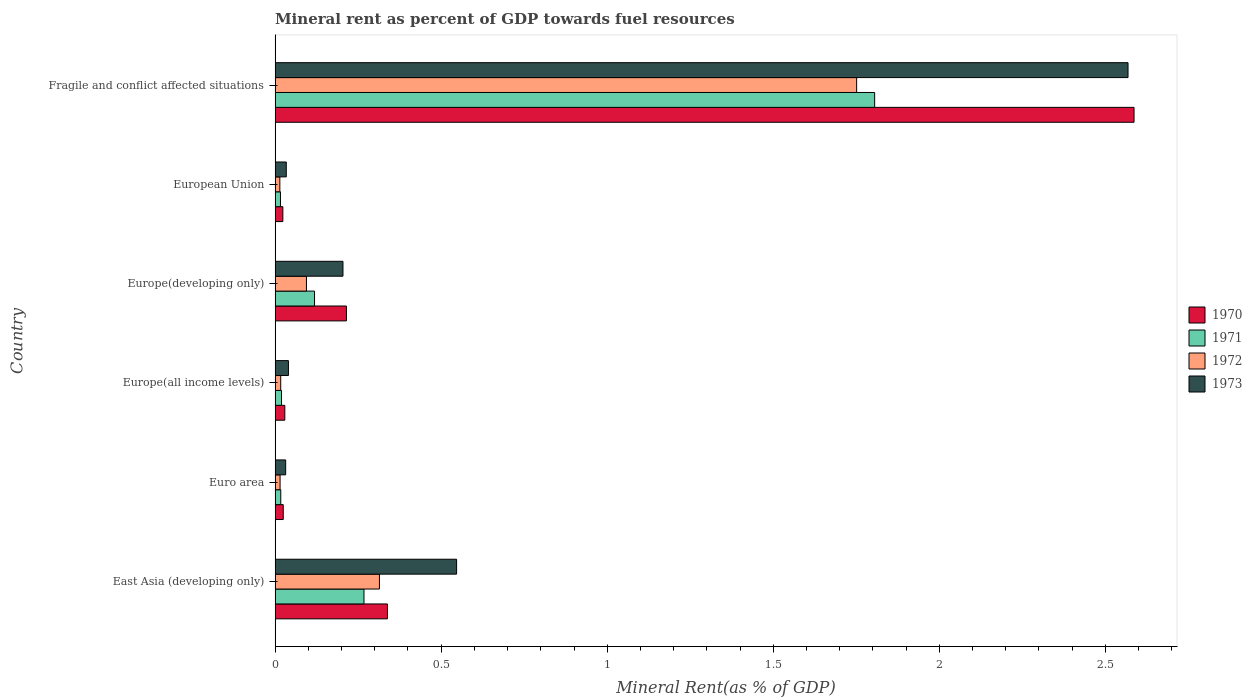How many groups of bars are there?
Offer a terse response. 6. Are the number of bars per tick equal to the number of legend labels?
Your response must be concise. Yes. Are the number of bars on each tick of the Y-axis equal?
Make the answer very short. Yes. How many bars are there on the 6th tick from the bottom?
Provide a short and direct response. 4. What is the label of the 5th group of bars from the top?
Keep it short and to the point. Euro area. What is the mineral rent in 1970 in East Asia (developing only)?
Offer a very short reply. 0.34. Across all countries, what is the maximum mineral rent in 1973?
Keep it short and to the point. 2.57. Across all countries, what is the minimum mineral rent in 1972?
Provide a short and direct response. 0.01. In which country was the mineral rent in 1973 maximum?
Ensure brevity in your answer.  Fragile and conflict affected situations. In which country was the mineral rent in 1973 minimum?
Your response must be concise. Euro area. What is the total mineral rent in 1971 in the graph?
Make the answer very short. 2.24. What is the difference between the mineral rent in 1973 in East Asia (developing only) and that in Europe(all income levels)?
Your answer should be compact. 0.51. What is the difference between the mineral rent in 1971 in Euro area and the mineral rent in 1970 in Europe(developing only)?
Your answer should be compact. -0.2. What is the average mineral rent in 1970 per country?
Your answer should be compact. 0.54. What is the difference between the mineral rent in 1970 and mineral rent in 1972 in European Union?
Offer a terse response. 0.01. In how many countries, is the mineral rent in 1973 greater than 1.4 %?
Your answer should be compact. 1. What is the ratio of the mineral rent in 1972 in Europe(all income levels) to that in Fragile and conflict affected situations?
Your answer should be compact. 0.01. Is the difference between the mineral rent in 1970 in Euro area and Europe(all income levels) greater than the difference between the mineral rent in 1972 in Euro area and Europe(all income levels)?
Provide a succinct answer. No. What is the difference between the highest and the second highest mineral rent in 1970?
Provide a short and direct response. 2.25. What is the difference between the highest and the lowest mineral rent in 1970?
Your response must be concise. 2.56. In how many countries, is the mineral rent in 1973 greater than the average mineral rent in 1973 taken over all countries?
Keep it short and to the point. 1. What does the 3rd bar from the top in Euro area represents?
Your response must be concise. 1971. What does the 4th bar from the bottom in Euro area represents?
Offer a terse response. 1973. How many bars are there?
Provide a succinct answer. 24. Are all the bars in the graph horizontal?
Provide a short and direct response. Yes. How many countries are there in the graph?
Provide a succinct answer. 6. Are the values on the major ticks of X-axis written in scientific E-notation?
Give a very brief answer. No. How are the legend labels stacked?
Ensure brevity in your answer.  Vertical. What is the title of the graph?
Your answer should be very brief. Mineral rent as percent of GDP towards fuel resources. Does "1975" appear as one of the legend labels in the graph?
Your response must be concise. No. What is the label or title of the X-axis?
Give a very brief answer. Mineral Rent(as % of GDP). What is the Mineral Rent(as % of GDP) in 1970 in East Asia (developing only)?
Your answer should be compact. 0.34. What is the Mineral Rent(as % of GDP) of 1971 in East Asia (developing only)?
Make the answer very short. 0.27. What is the Mineral Rent(as % of GDP) in 1972 in East Asia (developing only)?
Your answer should be very brief. 0.31. What is the Mineral Rent(as % of GDP) in 1973 in East Asia (developing only)?
Provide a succinct answer. 0.55. What is the Mineral Rent(as % of GDP) of 1970 in Euro area?
Your response must be concise. 0.02. What is the Mineral Rent(as % of GDP) in 1971 in Euro area?
Your answer should be very brief. 0.02. What is the Mineral Rent(as % of GDP) in 1972 in Euro area?
Offer a terse response. 0.02. What is the Mineral Rent(as % of GDP) in 1973 in Euro area?
Ensure brevity in your answer.  0.03. What is the Mineral Rent(as % of GDP) in 1970 in Europe(all income levels)?
Your answer should be very brief. 0.03. What is the Mineral Rent(as % of GDP) of 1971 in Europe(all income levels)?
Provide a succinct answer. 0.02. What is the Mineral Rent(as % of GDP) in 1972 in Europe(all income levels)?
Give a very brief answer. 0.02. What is the Mineral Rent(as % of GDP) in 1973 in Europe(all income levels)?
Keep it short and to the point. 0.04. What is the Mineral Rent(as % of GDP) in 1970 in Europe(developing only)?
Your answer should be compact. 0.21. What is the Mineral Rent(as % of GDP) in 1971 in Europe(developing only)?
Offer a very short reply. 0.12. What is the Mineral Rent(as % of GDP) in 1972 in Europe(developing only)?
Provide a succinct answer. 0.09. What is the Mineral Rent(as % of GDP) of 1973 in Europe(developing only)?
Provide a short and direct response. 0.2. What is the Mineral Rent(as % of GDP) in 1970 in European Union?
Provide a succinct answer. 0.02. What is the Mineral Rent(as % of GDP) of 1971 in European Union?
Make the answer very short. 0.02. What is the Mineral Rent(as % of GDP) in 1972 in European Union?
Provide a short and direct response. 0.01. What is the Mineral Rent(as % of GDP) of 1973 in European Union?
Offer a very short reply. 0.03. What is the Mineral Rent(as % of GDP) of 1970 in Fragile and conflict affected situations?
Ensure brevity in your answer.  2.59. What is the Mineral Rent(as % of GDP) of 1971 in Fragile and conflict affected situations?
Your answer should be very brief. 1.81. What is the Mineral Rent(as % of GDP) of 1972 in Fragile and conflict affected situations?
Offer a terse response. 1.75. What is the Mineral Rent(as % of GDP) in 1973 in Fragile and conflict affected situations?
Your answer should be very brief. 2.57. Across all countries, what is the maximum Mineral Rent(as % of GDP) in 1970?
Provide a succinct answer. 2.59. Across all countries, what is the maximum Mineral Rent(as % of GDP) of 1971?
Your response must be concise. 1.81. Across all countries, what is the maximum Mineral Rent(as % of GDP) of 1972?
Offer a terse response. 1.75. Across all countries, what is the maximum Mineral Rent(as % of GDP) of 1973?
Keep it short and to the point. 2.57. Across all countries, what is the minimum Mineral Rent(as % of GDP) in 1970?
Make the answer very short. 0.02. Across all countries, what is the minimum Mineral Rent(as % of GDP) of 1971?
Keep it short and to the point. 0.02. Across all countries, what is the minimum Mineral Rent(as % of GDP) in 1972?
Ensure brevity in your answer.  0.01. Across all countries, what is the minimum Mineral Rent(as % of GDP) of 1973?
Offer a very short reply. 0.03. What is the total Mineral Rent(as % of GDP) in 1970 in the graph?
Provide a short and direct response. 3.22. What is the total Mineral Rent(as % of GDP) in 1971 in the graph?
Offer a terse response. 2.24. What is the total Mineral Rent(as % of GDP) in 1972 in the graph?
Give a very brief answer. 2.21. What is the total Mineral Rent(as % of GDP) of 1973 in the graph?
Provide a short and direct response. 3.42. What is the difference between the Mineral Rent(as % of GDP) in 1970 in East Asia (developing only) and that in Euro area?
Your response must be concise. 0.31. What is the difference between the Mineral Rent(as % of GDP) of 1971 in East Asia (developing only) and that in Euro area?
Your response must be concise. 0.25. What is the difference between the Mineral Rent(as % of GDP) of 1972 in East Asia (developing only) and that in Euro area?
Your response must be concise. 0.3. What is the difference between the Mineral Rent(as % of GDP) of 1973 in East Asia (developing only) and that in Euro area?
Offer a terse response. 0.51. What is the difference between the Mineral Rent(as % of GDP) in 1970 in East Asia (developing only) and that in Europe(all income levels)?
Your response must be concise. 0.31. What is the difference between the Mineral Rent(as % of GDP) of 1971 in East Asia (developing only) and that in Europe(all income levels)?
Provide a succinct answer. 0.25. What is the difference between the Mineral Rent(as % of GDP) of 1972 in East Asia (developing only) and that in Europe(all income levels)?
Offer a terse response. 0.3. What is the difference between the Mineral Rent(as % of GDP) of 1973 in East Asia (developing only) and that in Europe(all income levels)?
Offer a terse response. 0.51. What is the difference between the Mineral Rent(as % of GDP) in 1970 in East Asia (developing only) and that in Europe(developing only)?
Your answer should be compact. 0.12. What is the difference between the Mineral Rent(as % of GDP) in 1971 in East Asia (developing only) and that in Europe(developing only)?
Your answer should be compact. 0.15. What is the difference between the Mineral Rent(as % of GDP) in 1972 in East Asia (developing only) and that in Europe(developing only)?
Your response must be concise. 0.22. What is the difference between the Mineral Rent(as % of GDP) of 1973 in East Asia (developing only) and that in Europe(developing only)?
Keep it short and to the point. 0.34. What is the difference between the Mineral Rent(as % of GDP) in 1970 in East Asia (developing only) and that in European Union?
Your answer should be compact. 0.31. What is the difference between the Mineral Rent(as % of GDP) in 1971 in East Asia (developing only) and that in European Union?
Your answer should be very brief. 0.25. What is the difference between the Mineral Rent(as % of GDP) in 1972 in East Asia (developing only) and that in European Union?
Give a very brief answer. 0.3. What is the difference between the Mineral Rent(as % of GDP) in 1973 in East Asia (developing only) and that in European Union?
Give a very brief answer. 0.51. What is the difference between the Mineral Rent(as % of GDP) of 1970 in East Asia (developing only) and that in Fragile and conflict affected situations?
Your answer should be very brief. -2.25. What is the difference between the Mineral Rent(as % of GDP) in 1971 in East Asia (developing only) and that in Fragile and conflict affected situations?
Your answer should be very brief. -1.54. What is the difference between the Mineral Rent(as % of GDP) in 1972 in East Asia (developing only) and that in Fragile and conflict affected situations?
Give a very brief answer. -1.44. What is the difference between the Mineral Rent(as % of GDP) of 1973 in East Asia (developing only) and that in Fragile and conflict affected situations?
Provide a succinct answer. -2.02. What is the difference between the Mineral Rent(as % of GDP) of 1970 in Euro area and that in Europe(all income levels)?
Provide a short and direct response. -0. What is the difference between the Mineral Rent(as % of GDP) in 1971 in Euro area and that in Europe(all income levels)?
Give a very brief answer. -0. What is the difference between the Mineral Rent(as % of GDP) of 1972 in Euro area and that in Europe(all income levels)?
Provide a short and direct response. -0. What is the difference between the Mineral Rent(as % of GDP) in 1973 in Euro area and that in Europe(all income levels)?
Provide a short and direct response. -0.01. What is the difference between the Mineral Rent(as % of GDP) of 1970 in Euro area and that in Europe(developing only)?
Provide a succinct answer. -0.19. What is the difference between the Mineral Rent(as % of GDP) in 1971 in Euro area and that in Europe(developing only)?
Offer a very short reply. -0.1. What is the difference between the Mineral Rent(as % of GDP) in 1972 in Euro area and that in Europe(developing only)?
Provide a short and direct response. -0.08. What is the difference between the Mineral Rent(as % of GDP) in 1973 in Euro area and that in Europe(developing only)?
Your answer should be very brief. -0.17. What is the difference between the Mineral Rent(as % of GDP) of 1970 in Euro area and that in European Union?
Keep it short and to the point. 0. What is the difference between the Mineral Rent(as % of GDP) of 1971 in Euro area and that in European Union?
Your answer should be very brief. 0. What is the difference between the Mineral Rent(as % of GDP) in 1972 in Euro area and that in European Union?
Provide a succinct answer. 0. What is the difference between the Mineral Rent(as % of GDP) of 1973 in Euro area and that in European Union?
Your answer should be very brief. -0. What is the difference between the Mineral Rent(as % of GDP) of 1970 in Euro area and that in Fragile and conflict affected situations?
Offer a very short reply. -2.56. What is the difference between the Mineral Rent(as % of GDP) of 1971 in Euro area and that in Fragile and conflict affected situations?
Give a very brief answer. -1.79. What is the difference between the Mineral Rent(as % of GDP) in 1972 in Euro area and that in Fragile and conflict affected situations?
Keep it short and to the point. -1.74. What is the difference between the Mineral Rent(as % of GDP) in 1973 in Euro area and that in Fragile and conflict affected situations?
Keep it short and to the point. -2.54. What is the difference between the Mineral Rent(as % of GDP) of 1970 in Europe(all income levels) and that in Europe(developing only)?
Provide a short and direct response. -0.19. What is the difference between the Mineral Rent(as % of GDP) of 1971 in Europe(all income levels) and that in Europe(developing only)?
Provide a short and direct response. -0.1. What is the difference between the Mineral Rent(as % of GDP) in 1972 in Europe(all income levels) and that in Europe(developing only)?
Provide a succinct answer. -0.08. What is the difference between the Mineral Rent(as % of GDP) in 1973 in Europe(all income levels) and that in Europe(developing only)?
Make the answer very short. -0.16. What is the difference between the Mineral Rent(as % of GDP) of 1970 in Europe(all income levels) and that in European Union?
Offer a terse response. 0.01. What is the difference between the Mineral Rent(as % of GDP) of 1971 in Europe(all income levels) and that in European Union?
Keep it short and to the point. 0. What is the difference between the Mineral Rent(as % of GDP) of 1972 in Europe(all income levels) and that in European Union?
Provide a short and direct response. 0. What is the difference between the Mineral Rent(as % of GDP) in 1973 in Europe(all income levels) and that in European Union?
Offer a terse response. 0.01. What is the difference between the Mineral Rent(as % of GDP) in 1970 in Europe(all income levels) and that in Fragile and conflict affected situations?
Your answer should be compact. -2.56. What is the difference between the Mineral Rent(as % of GDP) in 1971 in Europe(all income levels) and that in Fragile and conflict affected situations?
Provide a short and direct response. -1.79. What is the difference between the Mineral Rent(as % of GDP) in 1972 in Europe(all income levels) and that in Fragile and conflict affected situations?
Provide a succinct answer. -1.73. What is the difference between the Mineral Rent(as % of GDP) in 1973 in Europe(all income levels) and that in Fragile and conflict affected situations?
Your answer should be very brief. -2.53. What is the difference between the Mineral Rent(as % of GDP) of 1970 in Europe(developing only) and that in European Union?
Your answer should be very brief. 0.19. What is the difference between the Mineral Rent(as % of GDP) in 1971 in Europe(developing only) and that in European Union?
Provide a short and direct response. 0.1. What is the difference between the Mineral Rent(as % of GDP) of 1972 in Europe(developing only) and that in European Union?
Keep it short and to the point. 0.08. What is the difference between the Mineral Rent(as % of GDP) in 1973 in Europe(developing only) and that in European Union?
Offer a terse response. 0.17. What is the difference between the Mineral Rent(as % of GDP) in 1970 in Europe(developing only) and that in Fragile and conflict affected situations?
Your answer should be compact. -2.37. What is the difference between the Mineral Rent(as % of GDP) in 1971 in Europe(developing only) and that in Fragile and conflict affected situations?
Your answer should be compact. -1.69. What is the difference between the Mineral Rent(as % of GDP) in 1972 in Europe(developing only) and that in Fragile and conflict affected situations?
Offer a terse response. -1.66. What is the difference between the Mineral Rent(as % of GDP) in 1973 in Europe(developing only) and that in Fragile and conflict affected situations?
Give a very brief answer. -2.36. What is the difference between the Mineral Rent(as % of GDP) of 1970 in European Union and that in Fragile and conflict affected situations?
Offer a very short reply. -2.56. What is the difference between the Mineral Rent(as % of GDP) in 1971 in European Union and that in Fragile and conflict affected situations?
Your answer should be compact. -1.79. What is the difference between the Mineral Rent(as % of GDP) of 1972 in European Union and that in Fragile and conflict affected situations?
Give a very brief answer. -1.74. What is the difference between the Mineral Rent(as % of GDP) in 1973 in European Union and that in Fragile and conflict affected situations?
Your answer should be compact. -2.53. What is the difference between the Mineral Rent(as % of GDP) of 1970 in East Asia (developing only) and the Mineral Rent(as % of GDP) of 1971 in Euro area?
Your answer should be compact. 0.32. What is the difference between the Mineral Rent(as % of GDP) of 1970 in East Asia (developing only) and the Mineral Rent(as % of GDP) of 1972 in Euro area?
Your answer should be very brief. 0.32. What is the difference between the Mineral Rent(as % of GDP) of 1970 in East Asia (developing only) and the Mineral Rent(as % of GDP) of 1973 in Euro area?
Make the answer very short. 0.31. What is the difference between the Mineral Rent(as % of GDP) of 1971 in East Asia (developing only) and the Mineral Rent(as % of GDP) of 1972 in Euro area?
Ensure brevity in your answer.  0.25. What is the difference between the Mineral Rent(as % of GDP) in 1971 in East Asia (developing only) and the Mineral Rent(as % of GDP) in 1973 in Euro area?
Make the answer very short. 0.24. What is the difference between the Mineral Rent(as % of GDP) of 1972 in East Asia (developing only) and the Mineral Rent(as % of GDP) of 1973 in Euro area?
Offer a terse response. 0.28. What is the difference between the Mineral Rent(as % of GDP) in 1970 in East Asia (developing only) and the Mineral Rent(as % of GDP) in 1971 in Europe(all income levels)?
Make the answer very short. 0.32. What is the difference between the Mineral Rent(as % of GDP) in 1970 in East Asia (developing only) and the Mineral Rent(as % of GDP) in 1972 in Europe(all income levels)?
Provide a succinct answer. 0.32. What is the difference between the Mineral Rent(as % of GDP) in 1970 in East Asia (developing only) and the Mineral Rent(as % of GDP) in 1973 in Europe(all income levels)?
Your answer should be very brief. 0.3. What is the difference between the Mineral Rent(as % of GDP) of 1971 in East Asia (developing only) and the Mineral Rent(as % of GDP) of 1972 in Europe(all income levels)?
Offer a terse response. 0.25. What is the difference between the Mineral Rent(as % of GDP) of 1971 in East Asia (developing only) and the Mineral Rent(as % of GDP) of 1973 in Europe(all income levels)?
Give a very brief answer. 0.23. What is the difference between the Mineral Rent(as % of GDP) in 1972 in East Asia (developing only) and the Mineral Rent(as % of GDP) in 1973 in Europe(all income levels)?
Give a very brief answer. 0.27. What is the difference between the Mineral Rent(as % of GDP) in 1970 in East Asia (developing only) and the Mineral Rent(as % of GDP) in 1971 in Europe(developing only)?
Your answer should be compact. 0.22. What is the difference between the Mineral Rent(as % of GDP) in 1970 in East Asia (developing only) and the Mineral Rent(as % of GDP) in 1972 in Europe(developing only)?
Offer a terse response. 0.24. What is the difference between the Mineral Rent(as % of GDP) in 1970 in East Asia (developing only) and the Mineral Rent(as % of GDP) in 1973 in Europe(developing only)?
Keep it short and to the point. 0.13. What is the difference between the Mineral Rent(as % of GDP) of 1971 in East Asia (developing only) and the Mineral Rent(as % of GDP) of 1972 in Europe(developing only)?
Your answer should be compact. 0.17. What is the difference between the Mineral Rent(as % of GDP) of 1971 in East Asia (developing only) and the Mineral Rent(as % of GDP) of 1973 in Europe(developing only)?
Your answer should be compact. 0.06. What is the difference between the Mineral Rent(as % of GDP) of 1972 in East Asia (developing only) and the Mineral Rent(as % of GDP) of 1973 in Europe(developing only)?
Your response must be concise. 0.11. What is the difference between the Mineral Rent(as % of GDP) in 1970 in East Asia (developing only) and the Mineral Rent(as % of GDP) in 1971 in European Union?
Offer a very short reply. 0.32. What is the difference between the Mineral Rent(as % of GDP) of 1970 in East Asia (developing only) and the Mineral Rent(as % of GDP) of 1972 in European Union?
Offer a terse response. 0.32. What is the difference between the Mineral Rent(as % of GDP) in 1970 in East Asia (developing only) and the Mineral Rent(as % of GDP) in 1973 in European Union?
Ensure brevity in your answer.  0.3. What is the difference between the Mineral Rent(as % of GDP) in 1971 in East Asia (developing only) and the Mineral Rent(as % of GDP) in 1972 in European Union?
Ensure brevity in your answer.  0.25. What is the difference between the Mineral Rent(as % of GDP) in 1971 in East Asia (developing only) and the Mineral Rent(as % of GDP) in 1973 in European Union?
Your answer should be very brief. 0.23. What is the difference between the Mineral Rent(as % of GDP) in 1972 in East Asia (developing only) and the Mineral Rent(as % of GDP) in 1973 in European Union?
Offer a very short reply. 0.28. What is the difference between the Mineral Rent(as % of GDP) of 1970 in East Asia (developing only) and the Mineral Rent(as % of GDP) of 1971 in Fragile and conflict affected situations?
Your answer should be very brief. -1.47. What is the difference between the Mineral Rent(as % of GDP) in 1970 in East Asia (developing only) and the Mineral Rent(as % of GDP) in 1972 in Fragile and conflict affected situations?
Your response must be concise. -1.41. What is the difference between the Mineral Rent(as % of GDP) of 1970 in East Asia (developing only) and the Mineral Rent(as % of GDP) of 1973 in Fragile and conflict affected situations?
Your answer should be compact. -2.23. What is the difference between the Mineral Rent(as % of GDP) in 1971 in East Asia (developing only) and the Mineral Rent(as % of GDP) in 1972 in Fragile and conflict affected situations?
Your answer should be compact. -1.48. What is the difference between the Mineral Rent(as % of GDP) in 1971 in East Asia (developing only) and the Mineral Rent(as % of GDP) in 1973 in Fragile and conflict affected situations?
Make the answer very short. -2.3. What is the difference between the Mineral Rent(as % of GDP) in 1972 in East Asia (developing only) and the Mineral Rent(as % of GDP) in 1973 in Fragile and conflict affected situations?
Provide a succinct answer. -2.25. What is the difference between the Mineral Rent(as % of GDP) of 1970 in Euro area and the Mineral Rent(as % of GDP) of 1971 in Europe(all income levels)?
Your answer should be compact. 0.01. What is the difference between the Mineral Rent(as % of GDP) of 1970 in Euro area and the Mineral Rent(as % of GDP) of 1972 in Europe(all income levels)?
Ensure brevity in your answer.  0.01. What is the difference between the Mineral Rent(as % of GDP) in 1970 in Euro area and the Mineral Rent(as % of GDP) in 1973 in Europe(all income levels)?
Offer a very short reply. -0.02. What is the difference between the Mineral Rent(as % of GDP) in 1971 in Euro area and the Mineral Rent(as % of GDP) in 1973 in Europe(all income levels)?
Keep it short and to the point. -0.02. What is the difference between the Mineral Rent(as % of GDP) of 1972 in Euro area and the Mineral Rent(as % of GDP) of 1973 in Europe(all income levels)?
Your answer should be compact. -0.03. What is the difference between the Mineral Rent(as % of GDP) of 1970 in Euro area and the Mineral Rent(as % of GDP) of 1971 in Europe(developing only)?
Your answer should be very brief. -0.09. What is the difference between the Mineral Rent(as % of GDP) of 1970 in Euro area and the Mineral Rent(as % of GDP) of 1972 in Europe(developing only)?
Ensure brevity in your answer.  -0.07. What is the difference between the Mineral Rent(as % of GDP) in 1970 in Euro area and the Mineral Rent(as % of GDP) in 1973 in Europe(developing only)?
Make the answer very short. -0.18. What is the difference between the Mineral Rent(as % of GDP) of 1971 in Euro area and the Mineral Rent(as % of GDP) of 1972 in Europe(developing only)?
Make the answer very short. -0.08. What is the difference between the Mineral Rent(as % of GDP) in 1971 in Euro area and the Mineral Rent(as % of GDP) in 1973 in Europe(developing only)?
Offer a terse response. -0.19. What is the difference between the Mineral Rent(as % of GDP) of 1972 in Euro area and the Mineral Rent(as % of GDP) of 1973 in Europe(developing only)?
Offer a terse response. -0.19. What is the difference between the Mineral Rent(as % of GDP) of 1970 in Euro area and the Mineral Rent(as % of GDP) of 1971 in European Union?
Provide a short and direct response. 0.01. What is the difference between the Mineral Rent(as % of GDP) of 1970 in Euro area and the Mineral Rent(as % of GDP) of 1972 in European Union?
Provide a short and direct response. 0.01. What is the difference between the Mineral Rent(as % of GDP) of 1970 in Euro area and the Mineral Rent(as % of GDP) of 1973 in European Union?
Ensure brevity in your answer.  -0.01. What is the difference between the Mineral Rent(as % of GDP) of 1971 in Euro area and the Mineral Rent(as % of GDP) of 1972 in European Union?
Offer a very short reply. 0. What is the difference between the Mineral Rent(as % of GDP) in 1971 in Euro area and the Mineral Rent(as % of GDP) in 1973 in European Union?
Offer a very short reply. -0.02. What is the difference between the Mineral Rent(as % of GDP) in 1972 in Euro area and the Mineral Rent(as % of GDP) in 1973 in European Union?
Ensure brevity in your answer.  -0.02. What is the difference between the Mineral Rent(as % of GDP) of 1970 in Euro area and the Mineral Rent(as % of GDP) of 1971 in Fragile and conflict affected situations?
Make the answer very short. -1.78. What is the difference between the Mineral Rent(as % of GDP) of 1970 in Euro area and the Mineral Rent(as % of GDP) of 1972 in Fragile and conflict affected situations?
Offer a very short reply. -1.73. What is the difference between the Mineral Rent(as % of GDP) of 1970 in Euro area and the Mineral Rent(as % of GDP) of 1973 in Fragile and conflict affected situations?
Your answer should be compact. -2.54. What is the difference between the Mineral Rent(as % of GDP) of 1971 in Euro area and the Mineral Rent(as % of GDP) of 1972 in Fragile and conflict affected situations?
Give a very brief answer. -1.73. What is the difference between the Mineral Rent(as % of GDP) of 1971 in Euro area and the Mineral Rent(as % of GDP) of 1973 in Fragile and conflict affected situations?
Offer a terse response. -2.55. What is the difference between the Mineral Rent(as % of GDP) of 1972 in Euro area and the Mineral Rent(as % of GDP) of 1973 in Fragile and conflict affected situations?
Make the answer very short. -2.55. What is the difference between the Mineral Rent(as % of GDP) of 1970 in Europe(all income levels) and the Mineral Rent(as % of GDP) of 1971 in Europe(developing only)?
Make the answer very short. -0.09. What is the difference between the Mineral Rent(as % of GDP) of 1970 in Europe(all income levels) and the Mineral Rent(as % of GDP) of 1972 in Europe(developing only)?
Offer a terse response. -0.07. What is the difference between the Mineral Rent(as % of GDP) in 1970 in Europe(all income levels) and the Mineral Rent(as % of GDP) in 1973 in Europe(developing only)?
Provide a succinct answer. -0.18. What is the difference between the Mineral Rent(as % of GDP) in 1971 in Europe(all income levels) and the Mineral Rent(as % of GDP) in 1972 in Europe(developing only)?
Ensure brevity in your answer.  -0.08. What is the difference between the Mineral Rent(as % of GDP) of 1971 in Europe(all income levels) and the Mineral Rent(as % of GDP) of 1973 in Europe(developing only)?
Your response must be concise. -0.18. What is the difference between the Mineral Rent(as % of GDP) in 1972 in Europe(all income levels) and the Mineral Rent(as % of GDP) in 1973 in Europe(developing only)?
Make the answer very short. -0.19. What is the difference between the Mineral Rent(as % of GDP) of 1970 in Europe(all income levels) and the Mineral Rent(as % of GDP) of 1971 in European Union?
Offer a very short reply. 0.01. What is the difference between the Mineral Rent(as % of GDP) in 1970 in Europe(all income levels) and the Mineral Rent(as % of GDP) in 1972 in European Union?
Ensure brevity in your answer.  0.01. What is the difference between the Mineral Rent(as % of GDP) of 1970 in Europe(all income levels) and the Mineral Rent(as % of GDP) of 1973 in European Union?
Make the answer very short. -0. What is the difference between the Mineral Rent(as % of GDP) in 1971 in Europe(all income levels) and the Mineral Rent(as % of GDP) in 1972 in European Union?
Provide a succinct answer. 0.01. What is the difference between the Mineral Rent(as % of GDP) of 1971 in Europe(all income levels) and the Mineral Rent(as % of GDP) of 1973 in European Union?
Your response must be concise. -0.01. What is the difference between the Mineral Rent(as % of GDP) of 1972 in Europe(all income levels) and the Mineral Rent(as % of GDP) of 1973 in European Union?
Your response must be concise. -0.02. What is the difference between the Mineral Rent(as % of GDP) in 1970 in Europe(all income levels) and the Mineral Rent(as % of GDP) in 1971 in Fragile and conflict affected situations?
Your answer should be compact. -1.78. What is the difference between the Mineral Rent(as % of GDP) of 1970 in Europe(all income levels) and the Mineral Rent(as % of GDP) of 1972 in Fragile and conflict affected situations?
Your answer should be very brief. -1.72. What is the difference between the Mineral Rent(as % of GDP) of 1970 in Europe(all income levels) and the Mineral Rent(as % of GDP) of 1973 in Fragile and conflict affected situations?
Your answer should be compact. -2.54. What is the difference between the Mineral Rent(as % of GDP) in 1971 in Europe(all income levels) and the Mineral Rent(as % of GDP) in 1972 in Fragile and conflict affected situations?
Provide a succinct answer. -1.73. What is the difference between the Mineral Rent(as % of GDP) in 1971 in Europe(all income levels) and the Mineral Rent(as % of GDP) in 1973 in Fragile and conflict affected situations?
Your response must be concise. -2.55. What is the difference between the Mineral Rent(as % of GDP) of 1972 in Europe(all income levels) and the Mineral Rent(as % of GDP) of 1973 in Fragile and conflict affected situations?
Offer a very short reply. -2.55. What is the difference between the Mineral Rent(as % of GDP) of 1970 in Europe(developing only) and the Mineral Rent(as % of GDP) of 1971 in European Union?
Ensure brevity in your answer.  0.2. What is the difference between the Mineral Rent(as % of GDP) in 1970 in Europe(developing only) and the Mineral Rent(as % of GDP) in 1972 in European Union?
Keep it short and to the point. 0.2. What is the difference between the Mineral Rent(as % of GDP) in 1970 in Europe(developing only) and the Mineral Rent(as % of GDP) in 1973 in European Union?
Provide a short and direct response. 0.18. What is the difference between the Mineral Rent(as % of GDP) in 1971 in Europe(developing only) and the Mineral Rent(as % of GDP) in 1972 in European Union?
Offer a very short reply. 0.1. What is the difference between the Mineral Rent(as % of GDP) of 1971 in Europe(developing only) and the Mineral Rent(as % of GDP) of 1973 in European Union?
Offer a very short reply. 0.09. What is the difference between the Mineral Rent(as % of GDP) of 1972 in Europe(developing only) and the Mineral Rent(as % of GDP) of 1973 in European Union?
Offer a terse response. 0.06. What is the difference between the Mineral Rent(as % of GDP) in 1970 in Europe(developing only) and the Mineral Rent(as % of GDP) in 1971 in Fragile and conflict affected situations?
Provide a succinct answer. -1.59. What is the difference between the Mineral Rent(as % of GDP) in 1970 in Europe(developing only) and the Mineral Rent(as % of GDP) in 1972 in Fragile and conflict affected situations?
Provide a short and direct response. -1.54. What is the difference between the Mineral Rent(as % of GDP) of 1970 in Europe(developing only) and the Mineral Rent(as % of GDP) of 1973 in Fragile and conflict affected situations?
Ensure brevity in your answer.  -2.35. What is the difference between the Mineral Rent(as % of GDP) of 1971 in Europe(developing only) and the Mineral Rent(as % of GDP) of 1972 in Fragile and conflict affected situations?
Offer a terse response. -1.63. What is the difference between the Mineral Rent(as % of GDP) of 1971 in Europe(developing only) and the Mineral Rent(as % of GDP) of 1973 in Fragile and conflict affected situations?
Ensure brevity in your answer.  -2.45. What is the difference between the Mineral Rent(as % of GDP) of 1972 in Europe(developing only) and the Mineral Rent(as % of GDP) of 1973 in Fragile and conflict affected situations?
Provide a succinct answer. -2.47. What is the difference between the Mineral Rent(as % of GDP) in 1970 in European Union and the Mineral Rent(as % of GDP) in 1971 in Fragile and conflict affected situations?
Ensure brevity in your answer.  -1.78. What is the difference between the Mineral Rent(as % of GDP) of 1970 in European Union and the Mineral Rent(as % of GDP) of 1972 in Fragile and conflict affected situations?
Keep it short and to the point. -1.73. What is the difference between the Mineral Rent(as % of GDP) of 1970 in European Union and the Mineral Rent(as % of GDP) of 1973 in Fragile and conflict affected situations?
Your answer should be compact. -2.54. What is the difference between the Mineral Rent(as % of GDP) of 1971 in European Union and the Mineral Rent(as % of GDP) of 1972 in Fragile and conflict affected situations?
Your answer should be compact. -1.73. What is the difference between the Mineral Rent(as % of GDP) in 1971 in European Union and the Mineral Rent(as % of GDP) in 1973 in Fragile and conflict affected situations?
Make the answer very short. -2.55. What is the difference between the Mineral Rent(as % of GDP) in 1972 in European Union and the Mineral Rent(as % of GDP) in 1973 in Fragile and conflict affected situations?
Offer a very short reply. -2.55. What is the average Mineral Rent(as % of GDP) of 1970 per country?
Provide a succinct answer. 0.54. What is the average Mineral Rent(as % of GDP) of 1971 per country?
Your answer should be very brief. 0.37. What is the average Mineral Rent(as % of GDP) in 1972 per country?
Ensure brevity in your answer.  0.37. What is the average Mineral Rent(as % of GDP) in 1973 per country?
Give a very brief answer. 0.57. What is the difference between the Mineral Rent(as % of GDP) in 1970 and Mineral Rent(as % of GDP) in 1971 in East Asia (developing only)?
Offer a very short reply. 0.07. What is the difference between the Mineral Rent(as % of GDP) in 1970 and Mineral Rent(as % of GDP) in 1972 in East Asia (developing only)?
Offer a very short reply. 0.02. What is the difference between the Mineral Rent(as % of GDP) of 1970 and Mineral Rent(as % of GDP) of 1973 in East Asia (developing only)?
Your response must be concise. -0.21. What is the difference between the Mineral Rent(as % of GDP) of 1971 and Mineral Rent(as % of GDP) of 1972 in East Asia (developing only)?
Offer a terse response. -0.05. What is the difference between the Mineral Rent(as % of GDP) of 1971 and Mineral Rent(as % of GDP) of 1973 in East Asia (developing only)?
Give a very brief answer. -0.28. What is the difference between the Mineral Rent(as % of GDP) of 1972 and Mineral Rent(as % of GDP) of 1973 in East Asia (developing only)?
Make the answer very short. -0.23. What is the difference between the Mineral Rent(as % of GDP) of 1970 and Mineral Rent(as % of GDP) of 1971 in Euro area?
Offer a terse response. 0.01. What is the difference between the Mineral Rent(as % of GDP) of 1970 and Mineral Rent(as % of GDP) of 1972 in Euro area?
Offer a terse response. 0.01. What is the difference between the Mineral Rent(as % of GDP) in 1970 and Mineral Rent(as % of GDP) in 1973 in Euro area?
Keep it short and to the point. -0.01. What is the difference between the Mineral Rent(as % of GDP) of 1971 and Mineral Rent(as % of GDP) of 1972 in Euro area?
Provide a succinct answer. 0. What is the difference between the Mineral Rent(as % of GDP) in 1971 and Mineral Rent(as % of GDP) in 1973 in Euro area?
Provide a succinct answer. -0.01. What is the difference between the Mineral Rent(as % of GDP) in 1972 and Mineral Rent(as % of GDP) in 1973 in Euro area?
Your response must be concise. -0.02. What is the difference between the Mineral Rent(as % of GDP) of 1970 and Mineral Rent(as % of GDP) of 1971 in Europe(all income levels)?
Keep it short and to the point. 0.01. What is the difference between the Mineral Rent(as % of GDP) in 1970 and Mineral Rent(as % of GDP) in 1972 in Europe(all income levels)?
Offer a very short reply. 0.01. What is the difference between the Mineral Rent(as % of GDP) of 1970 and Mineral Rent(as % of GDP) of 1973 in Europe(all income levels)?
Keep it short and to the point. -0.01. What is the difference between the Mineral Rent(as % of GDP) in 1971 and Mineral Rent(as % of GDP) in 1972 in Europe(all income levels)?
Offer a terse response. 0. What is the difference between the Mineral Rent(as % of GDP) in 1971 and Mineral Rent(as % of GDP) in 1973 in Europe(all income levels)?
Keep it short and to the point. -0.02. What is the difference between the Mineral Rent(as % of GDP) in 1972 and Mineral Rent(as % of GDP) in 1973 in Europe(all income levels)?
Provide a succinct answer. -0.02. What is the difference between the Mineral Rent(as % of GDP) of 1970 and Mineral Rent(as % of GDP) of 1971 in Europe(developing only)?
Your response must be concise. 0.1. What is the difference between the Mineral Rent(as % of GDP) of 1970 and Mineral Rent(as % of GDP) of 1972 in Europe(developing only)?
Provide a short and direct response. 0.12. What is the difference between the Mineral Rent(as % of GDP) of 1970 and Mineral Rent(as % of GDP) of 1973 in Europe(developing only)?
Keep it short and to the point. 0.01. What is the difference between the Mineral Rent(as % of GDP) of 1971 and Mineral Rent(as % of GDP) of 1972 in Europe(developing only)?
Give a very brief answer. 0.02. What is the difference between the Mineral Rent(as % of GDP) in 1971 and Mineral Rent(as % of GDP) in 1973 in Europe(developing only)?
Offer a terse response. -0.09. What is the difference between the Mineral Rent(as % of GDP) in 1972 and Mineral Rent(as % of GDP) in 1973 in Europe(developing only)?
Give a very brief answer. -0.11. What is the difference between the Mineral Rent(as % of GDP) in 1970 and Mineral Rent(as % of GDP) in 1971 in European Union?
Provide a succinct answer. 0.01. What is the difference between the Mineral Rent(as % of GDP) in 1970 and Mineral Rent(as % of GDP) in 1972 in European Union?
Offer a terse response. 0.01. What is the difference between the Mineral Rent(as % of GDP) of 1970 and Mineral Rent(as % of GDP) of 1973 in European Union?
Keep it short and to the point. -0.01. What is the difference between the Mineral Rent(as % of GDP) of 1971 and Mineral Rent(as % of GDP) of 1972 in European Union?
Provide a short and direct response. 0. What is the difference between the Mineral Rent(as % of GDP) of 1971 and Mineral Rent(as % of GDP) of 1973 in European Union?
Your answer should be very brief. -0.02. What is the difference between the Mineral Rent(as % of GDP) in 1972 and Mineral Rent(as % of GDP) in 1973 in European Union?
Offer a terse response. -0.02. What is the difference between the Mineral Rent(as % of GDP) in 1970 and Mineral Rent(as % of GDP) in 1971 in Fragile and conflict affected situations?
Offer a terse response. 0.78. What is the difference between the Mineral Rent(as % of GDP) in 1970 and Mineral Rent(as % of GDP) in 1972 in Fragile and conflict affected situations?
Offer a terse response. 0.84. What is the difference between the Mineral Rent(as % of GDP) in 1970 and Mineral Rent(as % of GDP) in 1973 in Fragile and conflict affected situations?
Give a very brief answer. 0.02. What is the difference between the Mineral Rent(as % of GDP) of 1971 and Mineral Rent(as % of GDP) of 1972 in Fragile and conflict affected situations?
Give a very brief answer. 0.05. What is the difference between the Mineral Rent(as % of GDP) of 1971 and Mineral Rent(as % of GDP) of 1973 in Fragile and conflict affected situations?
Your answer should be very brief. -0.76. What is the difference between the Mineral Rent(as % of GDP) of 1972 and Mineral Rent(as % of GDP) of 1973 in Fragile and conflict affected situations?
Provide a short and direct response. -0.82. What is the ratio of the Mineral Rent(as % of GDP) of 1970 in East Asia (developing only) to that in Euro area?
Offer a very short reply. 13.76. What is the ratio of the Mineral Rent(as % of GDP) of 1971 in East Asia (developing only) to that in Euro area?
Provide a short and direct response. 15.65. What is the ratio of the Mineral Rent(as % of GDP) in 1972 in East Asia (developing only) to that in Euro area?
Your answer should be very brief. 20.91. What is the ratio of the Mineral Rent(as % of GDP) in 1973 in East Asia (developing only) to that in Euro area?
Give a very brief answer. 17.14. What is the ratio of the Mineral Rent(as % of GDP) of 1970 in East Asia (developing only) to that in Europe(all income levels)?
Ensure brevity in your answer.  11.55. What is the ratio of the Mineral Rent(as % of GDP) in 1971 in East Asia (developing only) to that in Europe(all income levels)?
Your answer should be compact. 13.8. What is the ratio of the Mineral Rent(as % of GDP) in 1972 in East Asia (developing only) to that in Europe(all income levels)?
Your answer should be compact. 18.52. What is the ratio of the Mineral Rent(as % of GDP) of 1973 in East Asia (developing only) to that in Europe(all income levels)?
Your answer should be very brief. 13.59. What is the ratio of the Mineral Rent(as % of GDP) of 1970 in East Asia (developing only) to that in Europe(developing only)?
Your response must be concise. 1.57. What is the ratio of the Mineral Rent(as % of GDP) in 1971 in East Asia (developing only) to that in Europe(developing only)?
Your response must be concise. 2.25. What is the ratio of the Mineral Rent(as % of GDP) of 1972 in East Asia (developing only) to that in Europe(developing only)?
Provide a succinct answer. 3.33. What is the ratio of the Mineral Rent(as % of GDP) of 1973 in East Asia (developing only) to that in Europe(developing only)?
Your response must be concise. 2.67. What is the ratio of the Mineral Rent(as % of GDP) of 1970 in East Asia (developing only) to that in European Union?
Provide a short and direct response. 14.48. What is the ratio of the Mineral Rent(as % of GDP) of 1971 in East Asia (developing only) to that in European Union?
Offer a very short reply. 16.48. What is the ratio of the Mineral Rent(as % of GDP) in 1972 in East Asia (developing only) to that in European Union?
Keep it short and to the point. 21.92. What is the ratio of the Mineral Rent(as % of GDP) in 1973 in East Asia (developing only) to that in European Union?
Provide a succinct answer. 16.21. What is the ratio of the Mineral Rent(as % of GDP) of 1970 in East Asia (developing only) to that in Fragile and conflict affected situations?
Offer a very short reply. 0.13. What is the ratio of the Mineral Rent(as % of GDP) in 1971 in East Asia (developing only) to that in Fragile and conflict affected situations?
Keep it short and to the point. 0.15. What is the ratio of the Mineral Rent(as % of GDP) in 1972 in East Asia (developing only) to that in Fragile and conflict affected situations?
Offer a terse response. 0.18. What is the ratio of the Mineral Rent(as % of GDP) in 1973 in East Asia (developing only) to that in Fragile and conflict affected situations?
Offer a terse response. 0.21. What is the ratio of the Mineral Rent(as % of GDP) of 1970 in Euro area to that in Europe(all income levels)?
Give a very brief answer. 0.84. What is the ratio of the Mineral Rent(as % of GDP) of 1971 in Euro area to that in Europe(all income levels)?
Provide a succinct answer. 0.88. What is the ratio of the Mineral Rent(as % of GDP) in 1972 in Euro area to that in Europe(all income levels)?
Give a very brief answer. 0.89. What is the ratio of the Mineral Rent(as % of GDP) in 1973 in Euro area to that in Europe(all income levels)?
Keep it short and to the point. 0.79. What is the ratio of the Mineral Rent(as % of GDP) in 1970 in Euro area to that in Europe(developing only)?
Ensure brevity in your answer.  0.11. What is the ratio of the Mineral Rent(as % of GDP) in 1971 in Euro area to that in Europe(developing only)?
Provide a succinct answer. 0.14. What is the ratio of the Mineral Rent(as % of GDP) in 1972 in Euro area to that in Europe(developing only)?
Keep it short and to the point. 0.16. What is the ratio of the Mineral Rent(as % of GDP) of 1973 in Euro area to that in Europe(developing only)?
Your answer should be very brief. 0.16. What is the ratio of the Mineral Rent(as % of GDP) in 1970 in Euro area to that in European Union?
Provide a succinct answer. 1.05. What is the ratio of the Mineral Rent(as % of GDP) in 1971 in Euro area to that in European Union?
Make the answer very short. 1.05. What is the ratio of the Mineral Rent(as % of GDP) of 1972 in Euro area to that in European Union?
Your answer should be compact. 1.05. What is the ratio of the Mineral Rent(as % of GDP) in 1973 in Euro area to that in European Union?
Keep it short and to the point. 0.95. What is the ratio of the Mineral Rent(as % of GDP) of 1970 in Euro area to that in Fragile and conflict affected situations?
Your response must be concise. 0.01. What is the ratio of the Mineral Rent(as % of GDP) of 1971 in Euro area to that in Fragile and conflict affected situations?
Provide a short and direct response. 0.01. What is the ratio of the Mineral Rent(as % of GDP) of 1972 in Euro area to that in Fragile and conflict affected situations?
Keep it short and to the point. 0.01. What is the ratio of the Mineral Rent(as % of GDP) in 1973 in Euro area to that in Fragile and conflict affected situations?
Provide a succinct answer. 0.01. What is the ratio of the Mineral Rent(as % of GDP) of 1970 in Europe(all income levels) to that in Europe(developing only)?
Provide a succinct answer. 0.14. What is the ratio of the Mineral Rent(as % of GDP) in 1971 in Europe(all income levels) to that in Europe(developing only)?
Offer a terse response. 0.16. What is the ratio of the Mineral Rent(as % of GDP) of 1972 in Europe(all income levels) to that in Europe(developing only)?
Offer a very short reply. 0.18. What is the ratio of the Mineral Rent(as % of GDP) of 1973 in Europe(all income levels) to that in Europe(developing only)?
Your response must be concise. 0.2. What is the ratio of the Mineral Rent(as % of GDP) of 1970 in Europe(all income levels) to that in European Union?
Give a very brief answer. 1.25. What is the ratio of the Mineral Rent(as % of GDP) of 1971 in Europe(all income levels) to that in European Union?
Make the answer very short. 1.19. What is the ratio of the Mineral Rent(as % of GDP) of 1972 in Europe(all income levels) to that in European Union?
Provide a short and direct response. 1.18. What is the ratio of the Mineral Rent(as % of GDP) of 1973 in Europe(all income levels) to that in European Union?
Your answer should be compact. 1.19. What is the ratio of the Mineral Rent(as % of GDP) in 1970 in Europe(all income levels) to that in Fragile and conflict affected situations?
Give a very brief answer. 0.01. What is the ratio of the Mineral Rent(as % of GDP) of 1971 in Europe(all income levels) to that in Fragile and conflict affected situations?
Offer a very short reply. 0.01. What is the ratio of the Mineral Rent(as % of GDP) of 1972 in Europe(all income levels) to that in Fragile and conflict affected situations?
Make the answer very short. 0.01. What is the ratio of the Mineral Rent(as % of GDP) in 1973 in Europe(all income levels) to that in Fragile and conflict affected situations?
Keep it short and to the point. 0.02. What is the ratio of the Mineral Rent(as % of GDP) in 1970 in Europe(developing only) to that in European Union?
Give a very brief answer. 9.2. What is the ratio of the Mineral Rent(as % of GDP) in 1971 in Europe(developing only) to that in European Union?
Keep it short and to the point. 7.31. What is the ratio of the Mineral Rent(as % of GDP) of 1972 in Europe(developing only) to that in European Union?
Ensure brevity in your answer.  6.59. What is the ratio of the Mineral Rent(as % of GDP) in 1973 in Europe(developing only) to that in European Union?
Keep it short and to the point. 6.06. What is the ratio of the Mineral Rent(as % of GDP) in 1970 in Europe(developing only) to that in Fragile and conflict affected situations?
Offer a very short reply. 0.08. What is the ratio of the Mineral Rent(as % of GDP) of 1971 in Europe(developing only) to that in Fragile and conflict affected situations?
Provide a short and direct response. 0.07. What is the ratio of the Mineral Rent(as % of GDP) of 1972 in Europe(developing only) to that in Fragile and conflict affected situations?
Ensure brevity in your answer.  0.05. What is the ratio of the Mineral Rent(as % of GDP) of 1973 in Europe(developing only) to that in Fragile and conflict affected situations?
Your answer should be compact. 0.08. What is the ratio of the Mineral Rent(as % of GDP) of 1970 in European Union to that in Fragile and conflict affected situations?
Give a very brief answer. 0.01. What is the ratio of the Mineral Rent(as % of GDP) of 1971 in European Union to that in Fragile and conflict affected situations?
Provide a succinct answer. 0.01. What is the ratio of the Mineral Rent(as % of GDP) of 1972 in European Union to that in Fragile and conflict affected situations?
Ensure brevity in your answer.  0.01. What is the ratio of the Mineral Rent(as % of GDP) of 1973 in European Union to that in Fragile and conflict affected situations?
Provide a succinct answer. 0.01. What is the difference between the highest and the second highest Mineral Rent(as % of GDP) of 1970?
Your answer should be compact. 2.25. What is the difference between the highest and the second highest Mineral Rent(as % of GDP) of 1971?
Your answer should be compact. 1.54. What is the difference between the highest and the second highest Mineral Rent(as % of GDP) of 1972?
Your response must be concise. 1.44. What is the difference between the highest and the second highest Mineral Rent(as % of GDP) of 1973?
Provide a short and direct response. 2.02. What is the difference between the highest and the lowest Mineral Rent(as % of GDP) of 1970?
Provide a short and direct response. 2.56. What is the difference between the highest and the lowest Mineral Rent(as % of GDP) in 1971?
Offer a very short reply. 1.79. What is the difference between the highest and the lowest Mineral Rent(as % of GDP) of 1972?
Your answer should be compact. 1.74. What is the difference between the highest and the lowest Mineral Rent(as % of GDP) of 1973?
Offer a very short reply. 2.54. 